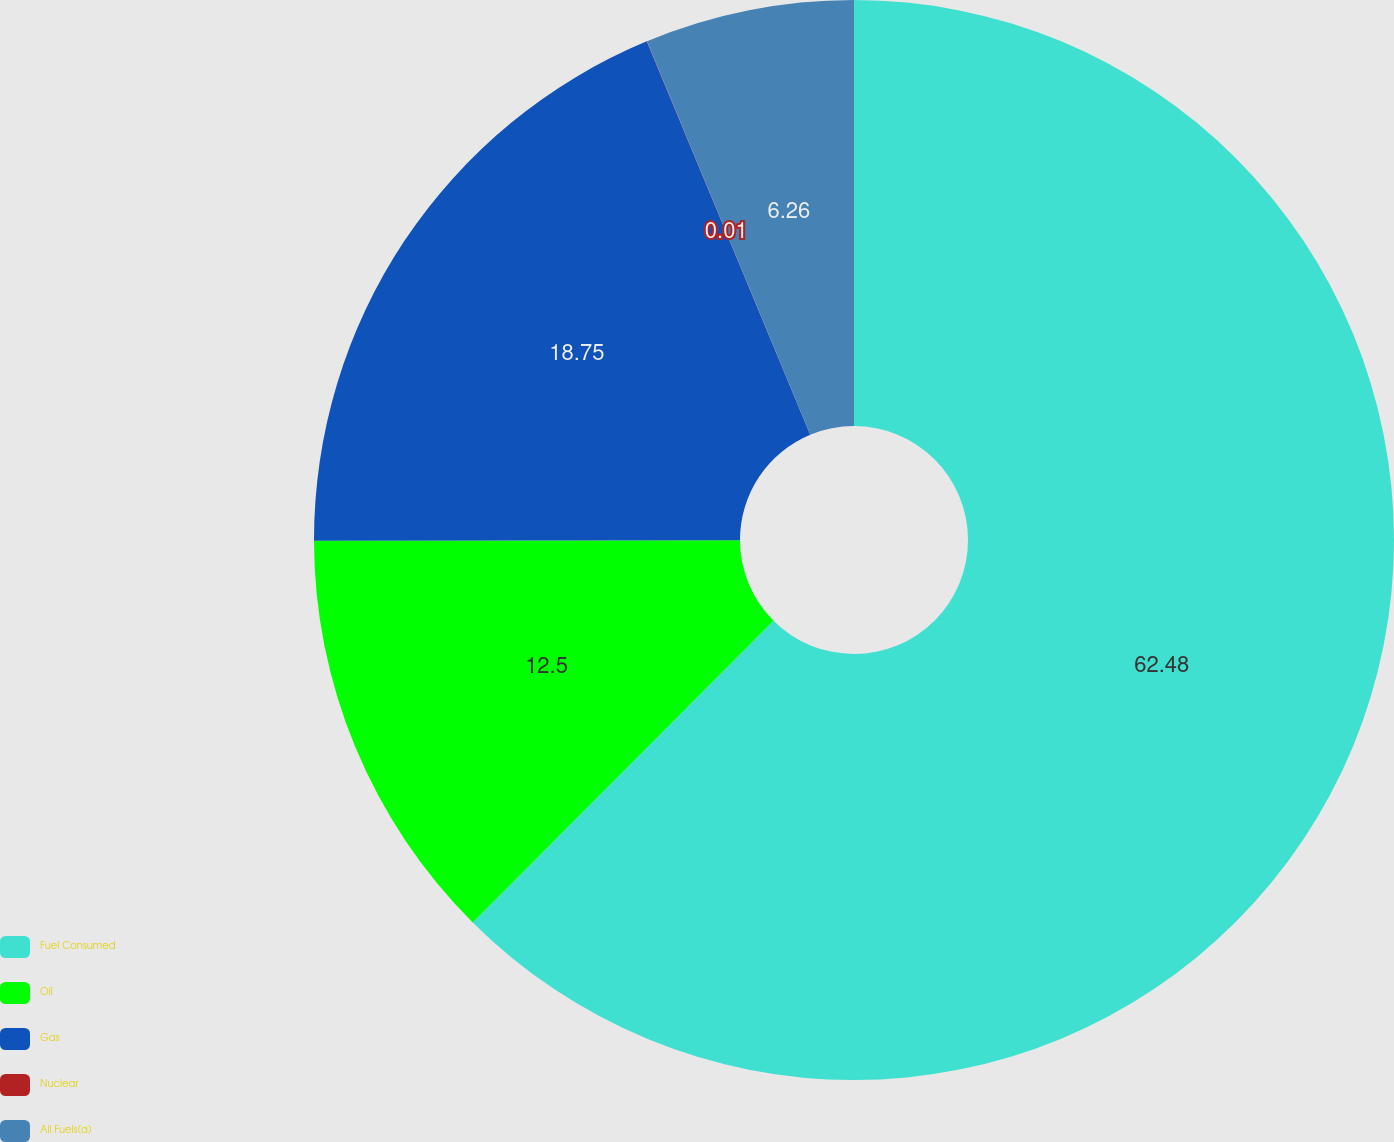Convert chart. <chart><loc_0><loc_0><loc_500><loc_500><pie_chart><fcel>Fuel Consumed<fcel>Oil<fcel>Gas<fcel>Nuclear<fcel>All Fuels(a)<nl><fcel>62.47%<fcel>12.5%<fcel>18.75%<fcel>0.01%<fcel>6.26%<nl></chart> 